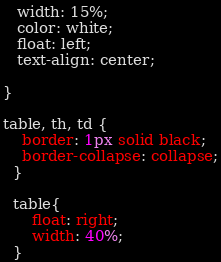Convert code to text. <code><loc_0><loc_0><loc_500><loc_500><_CSS_>   width: 15%;
   color: white;
   float: left;
   text-align: center;
   
}

table, th, td {
    border: 1px solid black;
    border-collapse: collapse;
  }

  table{
      float: right;
      width: 40%; 
  }</code> 